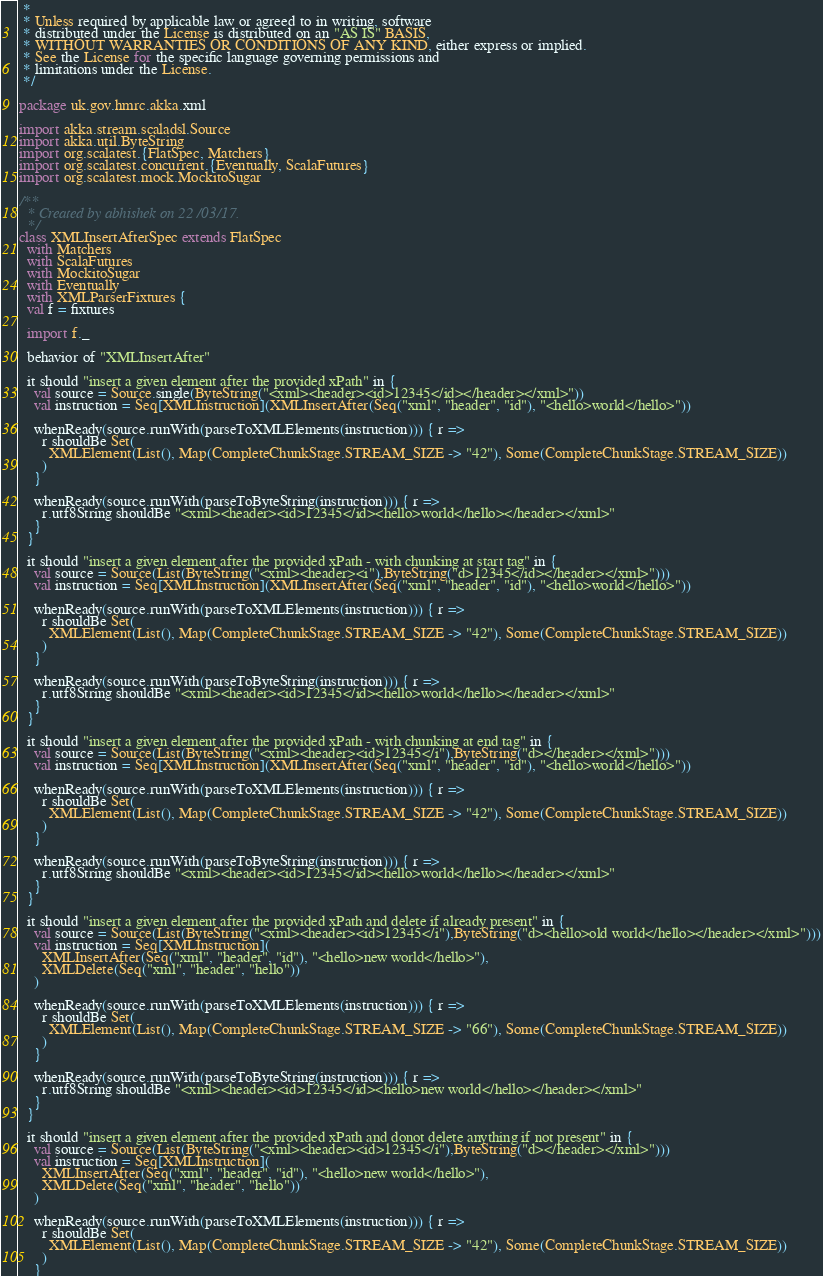<code> <loc_0><loc_0><loc_500><loc_500><_Scala_> *
 * Unless required by applicable law or agreed to in writing, software
 * distributed under the License is distributed on an "AS IS" BASIS,
 * WITHOUT WARRANTIES OR CONDITIONS OF ANY KIND, either express or implied.
 * See the License for the specific language governing permissions and
 * limitations under the License.
 */

package uk.gov.hmrc.akka.xml

import akka.stream.scaladsl.Source
import akka.util.ByteString
import org.scalatest.{FlatSpec, Matchers}
import org.scalatest.concurrent.{Eventually, ScalaFutures}
import org.scalatest.mock.MockitoSugar

/**
  * Created by abhishek on 22/03/17.
  */
class XMLInsertAfterSpec extends FlatSpec
  with Matchers
  with ScalaFutures
  with MockitoSugar
  with Eventually
  with XMLParserFixtures {
  val f = fixtures

  import f._

  behavior of "XMLInsertAfter"

  it should "insert a given element after the provided xPath" in {
    val source = Source.single(ByteString("<xml><header><id>12345</id></header></xml>"))
    val instruction = Seq[XMLInstruction](XMLInsertAfter(Seq("xml", "header", "id"), "<hello>world</hello>"))

    whenReady(source.runWith(parseToXMLElements(instruction))) { r =>
      r shouldBe Set(
        XMLElement(List(), Map(CompleteChunkStage.STREAM_SIZE -> "42"), Some(CompleteChunkStage.STREAM_SIZE))
      )
    }

    whenReady(source.runWith(parseToByteString(instruction))) { r =>
      r.utf8String shouldBe "<xml><header><id>12345</id><hello>world</hello></header></xml>"
    }
  }

  it should "insert a given element after the provided xPath - with chunking at start tag" in {
    val source = Source(List(ByteString("<xml><header><i"),ByteString("d>12345</id></header></xml>")))
    val instruction = Seq[XMLInstruction](XMLInsertAfter(Seq("xml", "header", "id"), "<hello>world</hello>"))

    whenReady(source.runWith(parseToXMLElements(instruction))) { r =>
      r shouldBe Set(
        XMLElement(List(), Map(CompleteChunkStage.STREAM_SIZE -> "42"), Some(CompleteChunkStage.STREAM_SIZE))
      )
    }

    whenReady(source.runWith(parseToByteString(instruction))) { r =>
      r.utf8String shouldBe "<xml><header><id>12345</id><hello>world</hello></header></xml>"
    }
  }

  it should "insert a given element after the provided xPath - with chunking at end tag" in {
    val source = Source(List(ByteString("<xml><header><id>12345</i"),ByteString("d></header></xml>")))
    val instruction = Seq[XMLInstruction](XMLInsertAfter(Seq("xml", "header", "id"), "<hello>world</hello>"))

    whenReady(source.runWith(parseToXMLElements(instruction))) { r =>
      r shouldBe Set(
        XMLElement(List(), Map(CompleteChunkStage.STREAM_SIZE -> "42"), Some(CompleteChunkStage.STREAM_SIZE))
      )
    }

    whenReady(source.runWith(parseToByteString(instruction))) { r =>
      r.utf8String shouldBe "<xml><header><id>12345</id><hello>world</hello></header></xml>"
    }
  }

  it should "insert a given element after the provided xPath and delete if already present" in {
    val source = Source(List(ByteString("<xml><header><id>12345</i"),ByteString("d><hello>old world</hello></header></xml>")))
    val instruction = Seq[XMLInstruction](
      XMLInsertAfter(Seq("xml", "header", "id"), "<hello>new world</hello>"),
      XMLDelete(Seq("xml", "header", "hello"))
    )

    whenReady(source.runWith(parseToXMLElements(instruction))) { r =>
      r shouldBe Set(
        XMLElement(List(), Map(CompleteChunkStage.STREAM_SIZE -> "66"), Some(CompleteChunkStage.STREAM_SIZE))
      )
    }

    whenReady(source.runWith(parseToByteString(instruction))) { r =>
      r.utf8String shouldBe "<xml><header><id>12345</id><hello>new world</hello></header></xml>"
    }
  }

  it should "insert a given element after the provided xPath and donot delete anything if not present" in {
    val source = Source(List(ByteString("<xml><header><id>12345</i"),ByteString("d></header></xml>")))
    val instruction = Seq[XMLInstruction](
      XMLInsertAfter(Seq("xml", "header", "id"), "<hello>new world</hello>"),
      XMLDelete(Seq("xml", "header", "hello"))
    )

    whenReady(source.runWith(parseToXMLElements(instruction))) { r =>
      r shouldBe Set(
        XMLElement(List(), Map(CompleteChunkStage.STREAM_SIZE -> "42"), Some(CompleteChunkStage.STREAM_SIZE))
      )
    }
</code> 